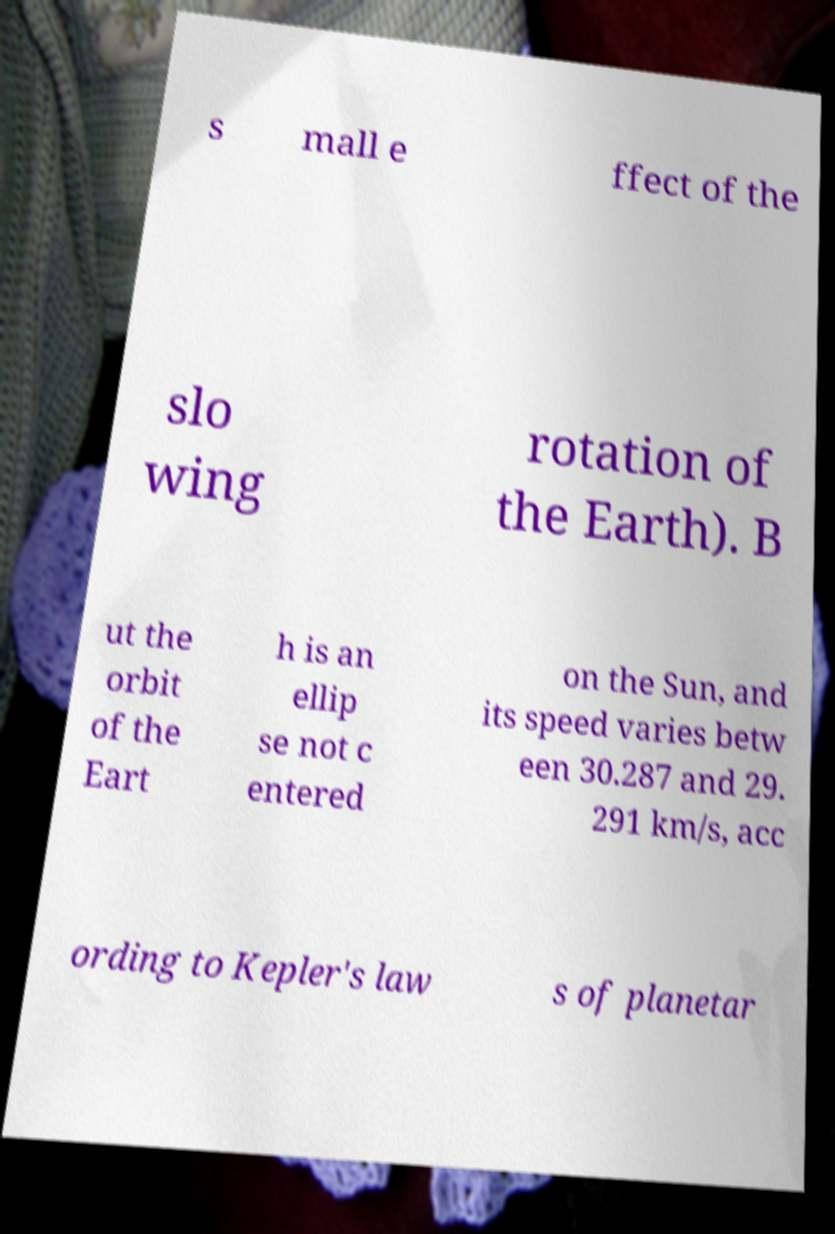Could you extract and type out the text from this image? s mall e ffect of the slo wing rotation of the Earth). B ut the orbit of the Eart h is an ellip se not c entered on the Sun, and its speed varies betw een 30.287 and 29. 291 km/s, acc ording to Kepler's law s of planetar 